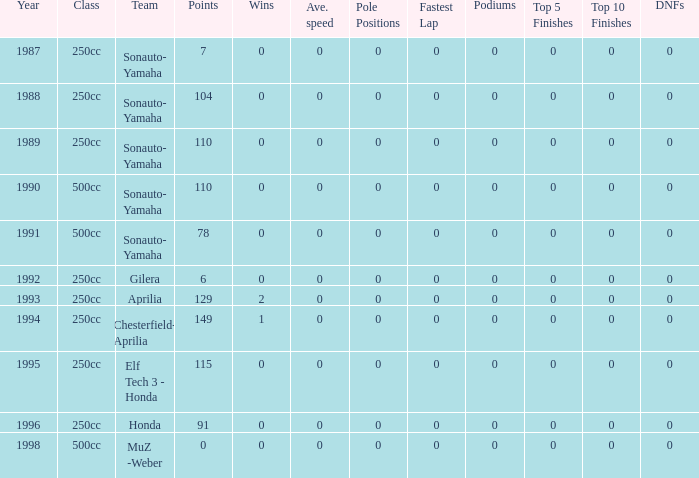How many wins did the team, which had more than 110 points, have in 1989? None. 